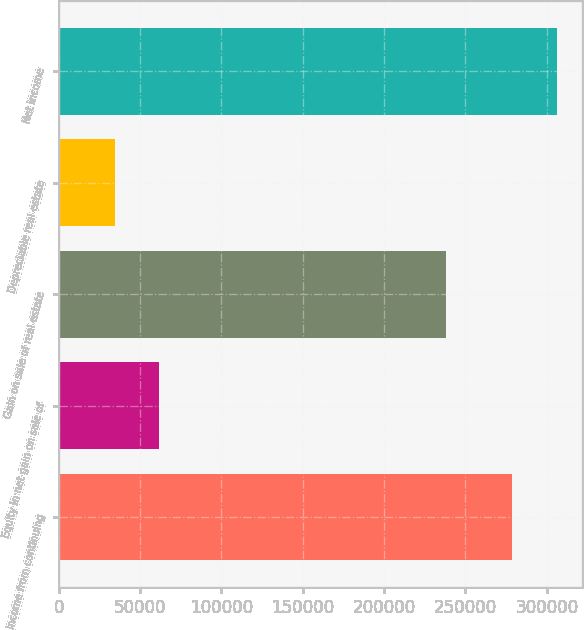Convert chart. <chart><loc_0><loc_0><loc_500><loc_500><bar_chart><fcel>Income from continuing<fcel>Equity in net gain on sale of<fcel>Gain on sale of real estate<fcel>Depreciable real estate<fcel>Net income<nl><fcel>278911<fcel>61587<fcel>238116<fcel>34421.5<fcel>306076<nl></chart> 